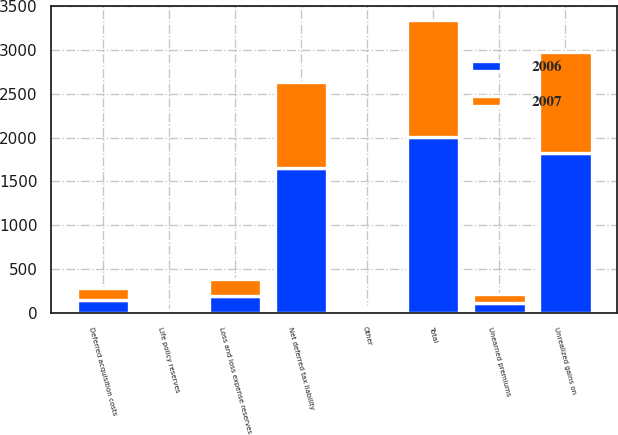<chart> <loc_0><loc_0><loc_500><loc_500><stacked_bar_chart><ecel><fcel>Unrealized gains on<fcel>Deferred acquisition costs<fcel>Other<fcel>Total<fcel>Loss and loss expense reserves<fcel>Unearned premiums<fcel>Life policy reserves<fcel>Net deferred tax liability<nl><fcel>2007<fcel>1158<fcel>145<fcel>35<fcel>1338<fcel>200<fcel>108<fcel>13<fcel>977<nl><fcel>2006<fcel>1824<fcel>142<fcel>36<fcel>2002<fcel>190<fcel>109<fcel>22<fcel>1653<nl></chart> 